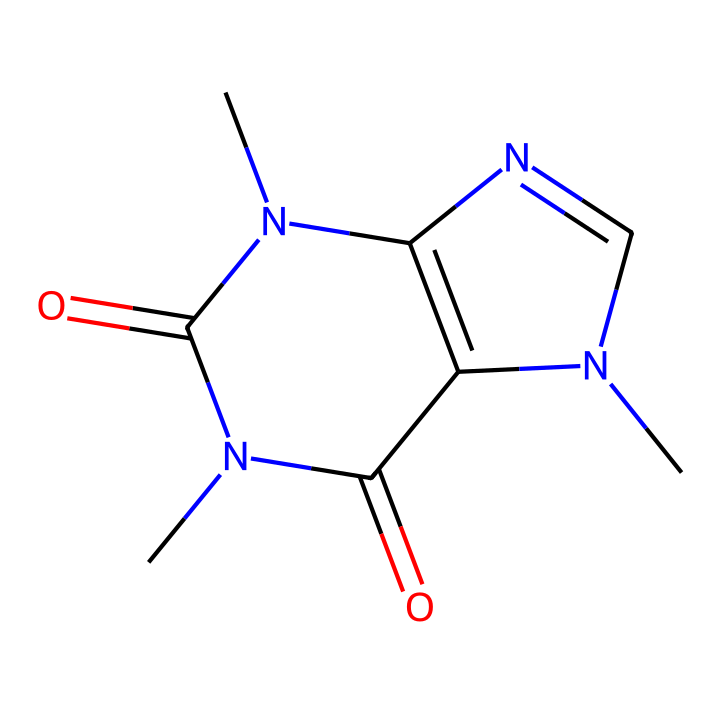how many nitrogen atoms are in caffeine's structure? By examining the SMILES representation, we see that there are three instances of 'N' indicating nitrogen atoms in the structure.
Answer: three what is the molecular formula of caffeine? Caffeine's structure shows it contains 8 carbon atoms (C), 10 hydrogen atoms (H), and 4 nitrogen atoms (N), giving the molecular formula C8H10N4O2.
Answer: C8H10N4O2 which functional groups are present in caffeine? The presence of nitrogen atoms and carbonyl groups (C=O) in the structure indicates that caffeine contains amine (due to the nitrogen) and amide (due to the carbonyl) functional groups.
Answer: amine and amide how many carbon atoms are present in the caffeine structure? In the SMILES representation, counting the 'C' letters, we find that there are a total of 8 carbon atoms in caffeine.
Answer: eight what type of compound is caffeine classified as? The structure contains multiple nitrogen atoms and exhibits properties typically associated with stimulants; thus, caffeine is classified as an alkaloid.
Answer: alkaloid what type of bonding is predominantly found in caffeine? The structure features single and double bonds, indicating both covalent bond types; the nitrogen-carbon and carbon-oxygen interactions are primarily covalent bonds.
Answer: covalent how many rings are present in the caffeine structure? Analyzing the connections in the SMILES representation, it reveals two fused rings, indicating the presence of two rings within the caffeine molecule.
Answer: two 